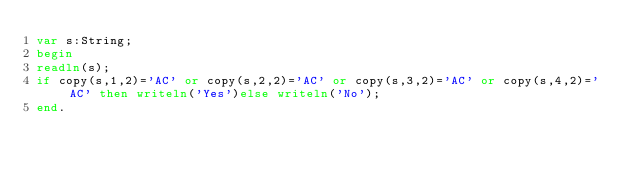<code> <loc_0><loc_0><loc_500><loc_500><_Pascal_>var s:String;
begin
readln(s);
if copy(s,1,2)='AC' or copy(s,2,2)='AC' or copy(s,3,2)='AC' or copy(s,4,2)='AC' then writeln('Yes')else writeln('No');
end.</code> 